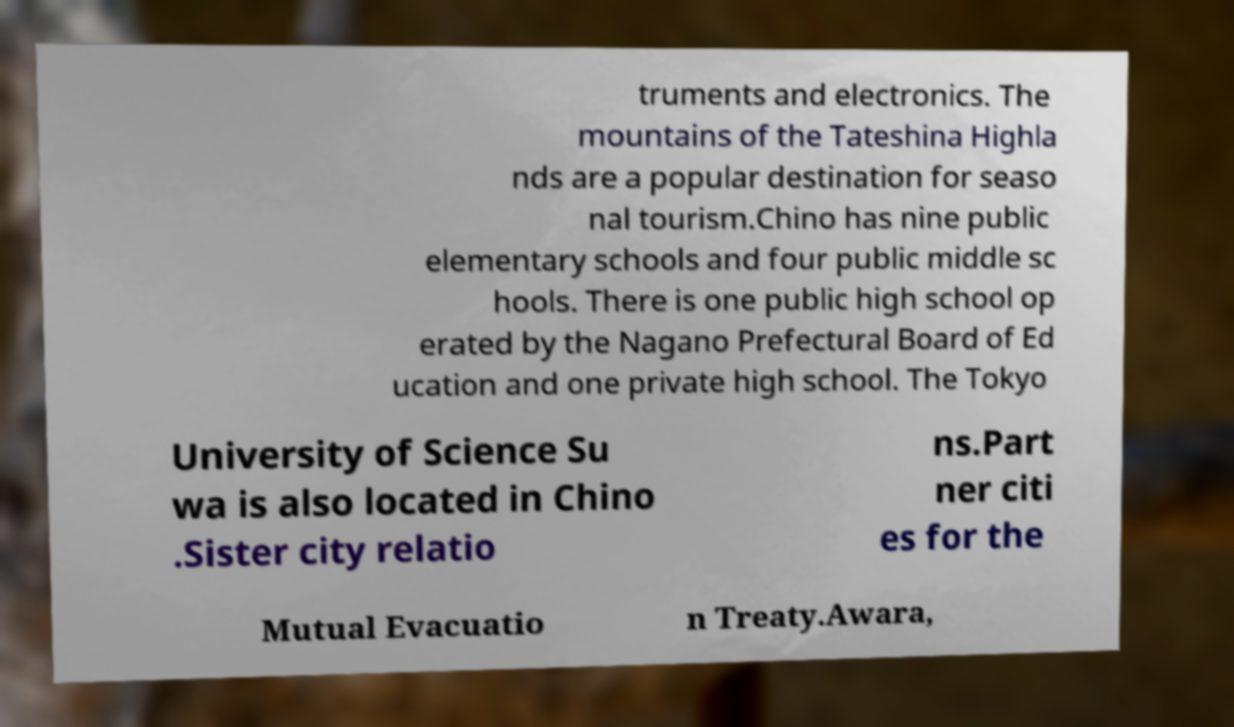Can you read and provide the text displayed in the image?This photo seems to have some interesting text. Can you extract and type it out for me? truments and electronics. The mountains of the Tateshina Highla nds are a popular destination for seaso nal tourism.Chino has nine public elementary schools and four public middle sc hools. There is one public high school op erated by the Nagano Prefectural Board of Ed ucation and one private high school. The Tokyo University of Science Su wa is also located in Chino .Sister city relatio ns.Part ner citi es for the Mutual Evacuatio n Treaty.Awara, 